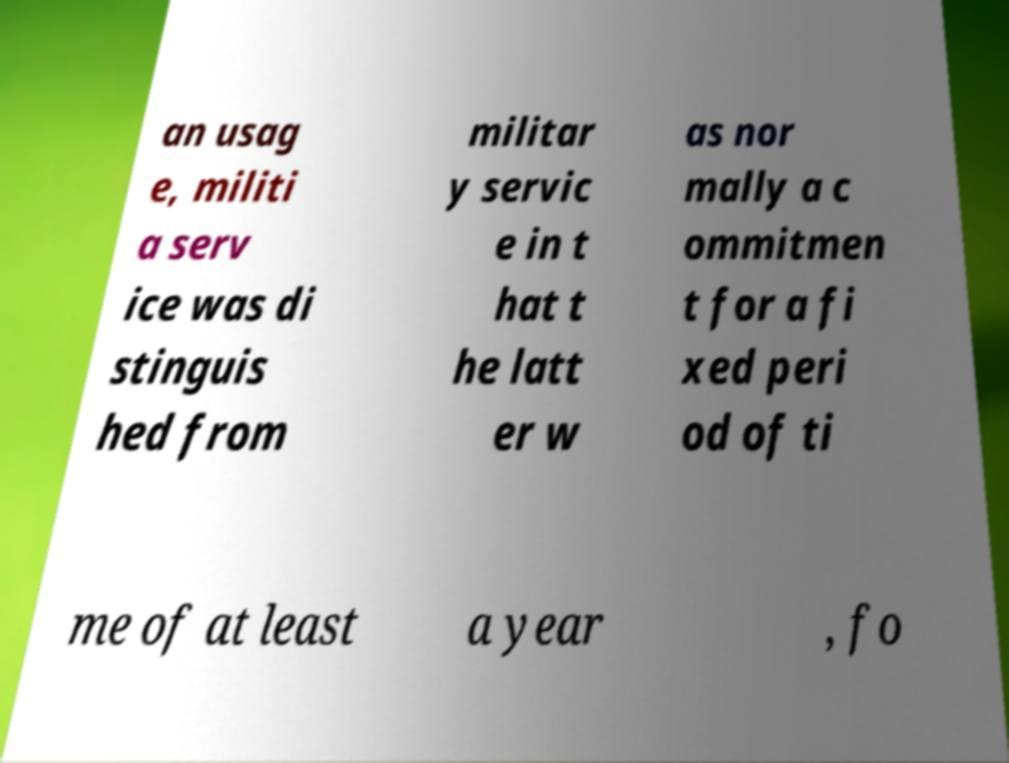Please identify and transcribe the text found in this image. an usag e, militi a serv ice was di stinguis hed from militar y servic e in t hat t he latt er w as nor mally a c ommitmen t for a fi xed peri od of ti me of at least a year , fo 